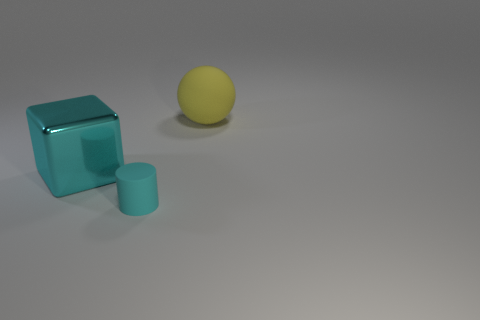Add 3 yellow shiny cylinders. How many objects exist? 6 Subtract all spheres. How many objects are left? 2 Subtract 0 green blocks. How many objects are left? 3 Subtract all cylinders. Subtract all cyan cylinders. How many objects are left? 1 Add 2 large cyan things. How many large cyan things are left? 3 Add 1 large cyan objects. How many large cyan objects exist? 2 